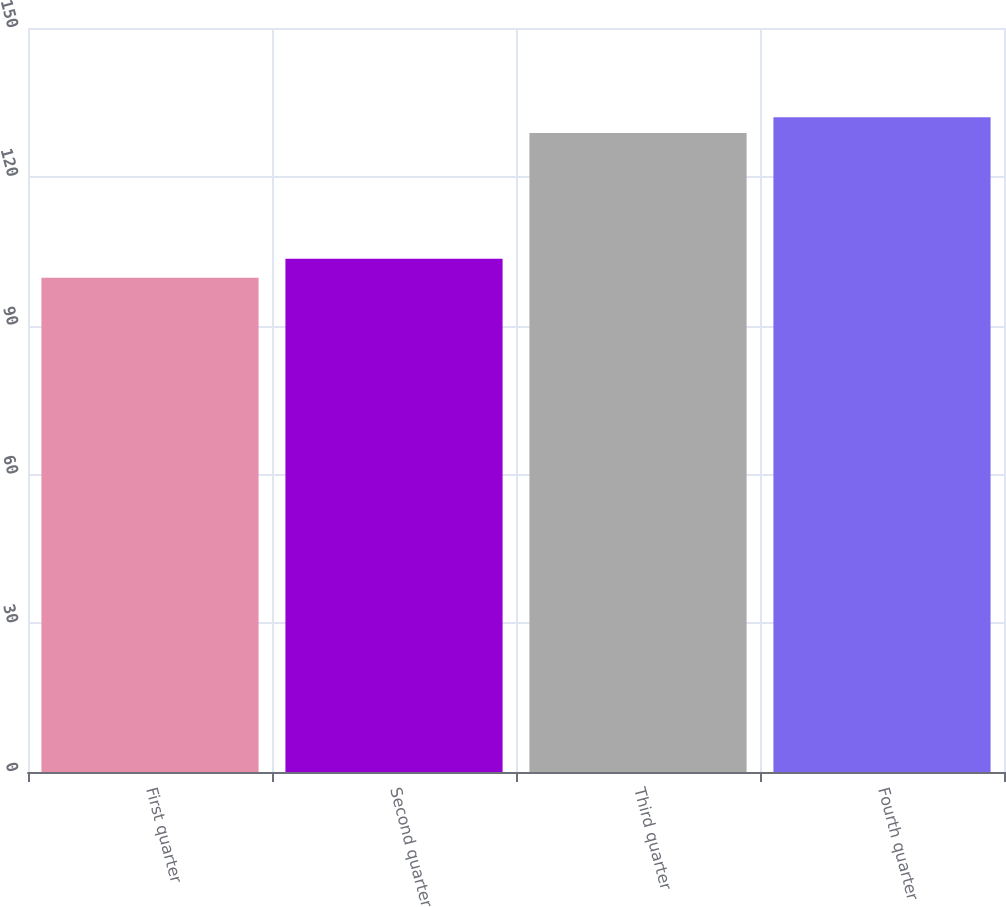<chart> <loc_0><loc_0><loc_500><loc_500><bar_chart><fcel>First quarter<fcel>Second quarter<fcel>Third quarter<fcel>Fourth quarter<nl><fcel>99.66<fcel>103.47<fcel>128.85<fcel>132.03<nl></chart> 